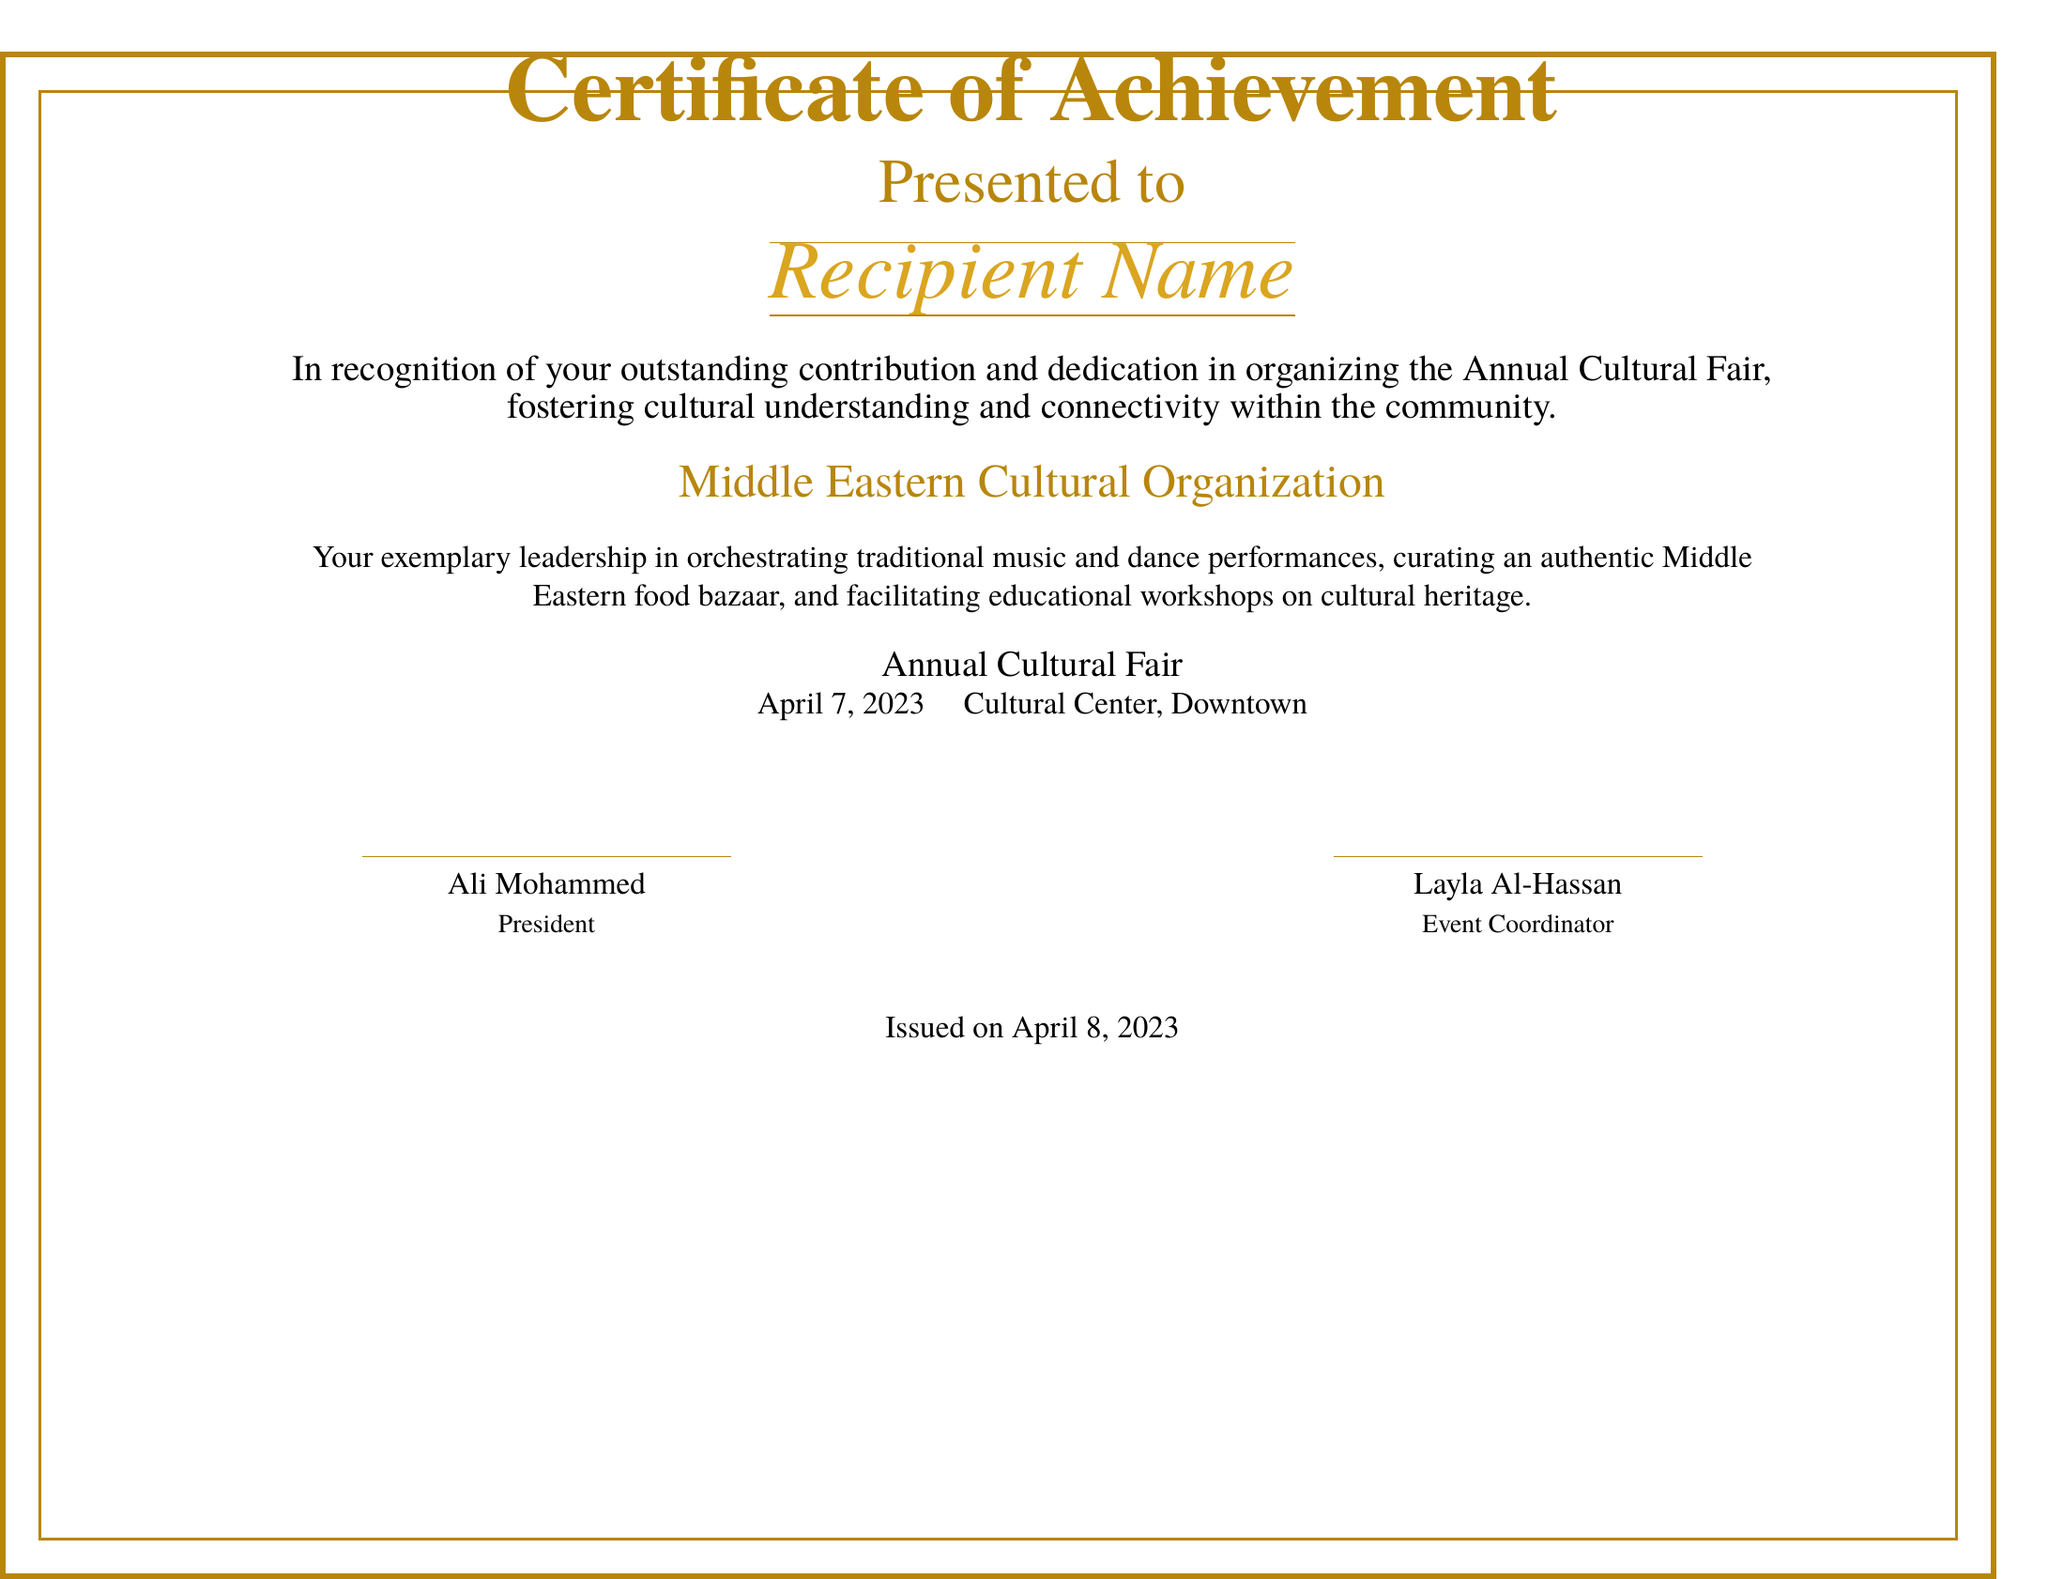what is the title of the certificate? The title of the certificate is prominently displayed at the top of the document.
Answer: Certificate of Achievement who is the recipient of the certificate? The recipient's name is highlighted in italics in the document.
Answer: Recipient Name what event is the certificate recognizing? The event recognized in the certificate is stated in the description.
Answer: Annual Cultural Fair what is the date of the event? The date of the event is mentioned in the lower section of the document.
Answer: April 7, 2023 who issued the certificate? The names of the individuals who issued the certificate are listed at the bottom.
Answer: Ali Mohammed and Layla Al-Hassan what organization is associated with the certificate? The organization that presented the certificate is mentioned above the event details.
Answer: Middle Eastern Cultural Organization what type of activities were organized at the event? The types of activities organized at the event are described in the recognition statement.
Answer: Traditional music and dance performances, food bazaar, educational workshops when was the certificate issued? The issuance date of the certificate is stated at the bottom of the document.
Answer: April 8, 2023 what color is used for the title? The color of the title is specified in the document.
Answer: Dark gold 